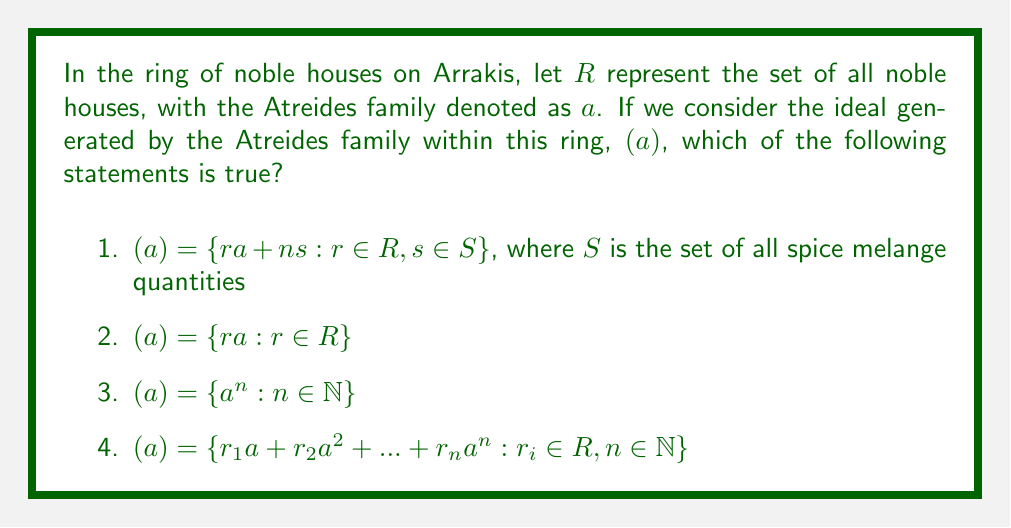Solve this math problem. To solve this problem, we need to understand the concept of an ideal in ring theory and apply it to the context of the Dune universe.

1) First, recall that in ring theory, an ideal $I$ of a ring $R$ is a subset of $R$ that is closed under addition and multiplication by any element of $R$.

2) The ideal generated by an element $a$ in a ring $R$, denoted as $(a)$, is the smallest ideal of $R$ containing $a$.

3) In the context of Dune, we can think of the ring of noble houses as a mathematical structure where each house is an element, and operations between houses might represent alliances, conflicts, or other interactions.

4) The ideal generated by the Atreides family $(a)$ would then represent all possible "combinations" of the Atreides with other noble houses through the ring operations.

5) Now, let's examine each option:

   Option 1 is incorrect because it introduces an external set $S$ (spice quantities) which is not part of the original ring definition.
   
   Option 3 is incorrect because it only includes powers of $a$, which is too restrictive for an ideal.
   
   Option 4 is incorrect because it only includes polynomial-like expressions in $a$, which is also too restrictive.
   
   Option 2 is correct. It represents all elements of $R$ multiplied by $a$, which is precisely the definition of the principal ideal generated by $a$.

6) In the context of Dune, $(a) = \{ra : r \in R\}$ would represent all possible interactions or combinations of the Atreides family with other noble houses.
Answer: The correct answer is option 2: $(a) = \{ra : r \in R\}$ 